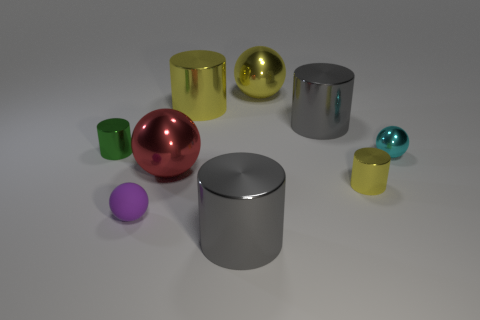Subtract all big shiny cylinders. How many cylinders are left? 2 Add 1 green rubber blocks. How many objects exist? 10 Subtract all balls. How many objects are left? 5 Subtract all yellow cubes. How many green cylinders are left? 1 Subtract all gray cylinders. How many cylinders are left? 3 Subtract 2 cylinders. How many cylinders are left? 3 Add 5 yellow shiny balls. How many yellow shiny balls are left? 6 Add 2 small blue rubber objects. How many small blue rubber objects exist? 2 Subtract 0 brown blocks. How many objects are left? 9 Subtract all brown spheres. Subtract all green cubes. How many spheres are left? 4 